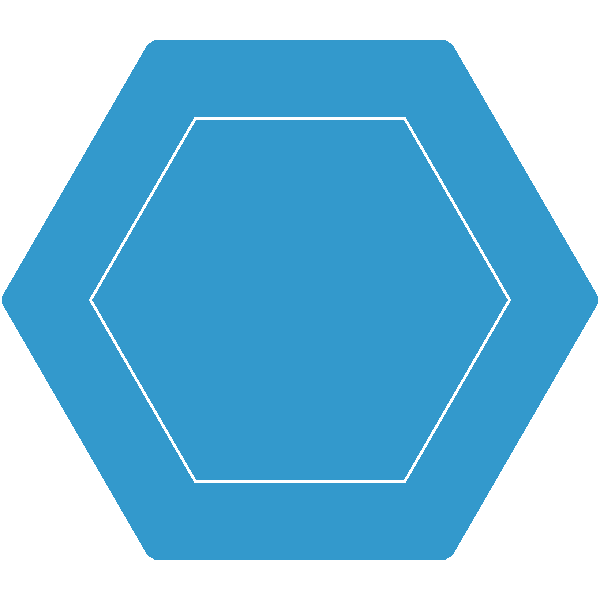A charitable organization is designing a new logo with rotational symmetry. The logo consists of a regular hexagon with smaller rotated hexagons inside, as shown in the figure. How many degrees must the logo be rotated to achieve a configuration indistinguishable from its original position? To determine the rotational symmetry of the logo, we need to follow these steps:

1. Identify the shape: The main shape is a regular hexagon.

2. Understand rotational symmetry: Rotational symmetry occurs when an object can be rotated about its center and appear unchanged.

3. Calculate the rotational symmetry of a regular hexagon:
   - A regular hexagon has 6 sides and 6 vertices.
   - The angle between two adjacent vertices from the center is $\frac{360°}{6} = 60°$.

4. Observe the internal structure:
   - The smaller hexagons inside are also rotated at 60° intervals.
   - This internal structure aligns with the rotational symmetry of the main hexagon.

5. Determine the smallest rotation for indistinguishable configuration:
   - Any rotation of 60° or multiples of 60° will produce an indistinguishable configuration.
   - The smallest positive rotation that achieves this is 60°.

Therefore, the logo must be rotated 60° to achieve a configuration indistinguishable from its original position.
Answer: 60° 